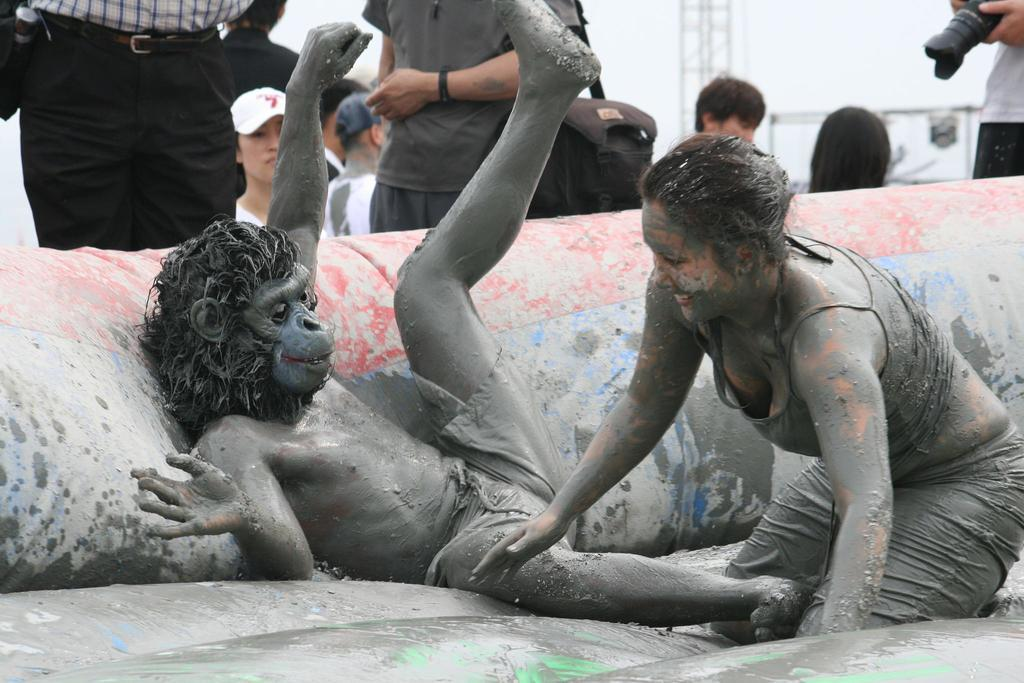What are the two people in the image doing? The two people in the image are playing. What is the surface they are playing on? They are playing in black soil. Are there any other people present in the image? Yes, there are other people standing behind them in the image. What type of cushion can be seen in the image? There is no cushion present in the image. What part of the human body is visible in the image? The image does not show any exposed flesh; it only shows people playing in black soil. 